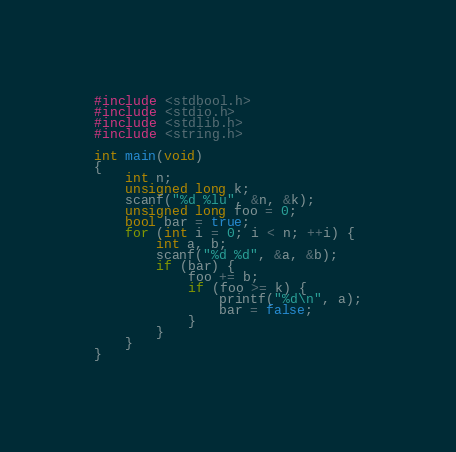<code> <loc_0><loc_0><loc_500><loc_500><_C_>#include <stdbool.h>
#include <stdio.h>
#include <stdlib.h>
#include <string.h>

int main(void)
{
	int n;
	unsigned long k;
	scanf("%d %lu", &n, &k);
	unsigned long foo = 0;
	bool bar = true;
	for (int i = 0; i < n; ++i) {
		int a, b;
		scanf("%d %d", &a, &b);
		if (bar) {
			foo += b;
			if (foo >= k) {
				printf("%d\n", a);
				bar = false;
			}
		}
	}
}
</code> 